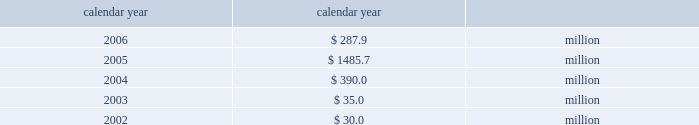Taxes .
If group or its bermuda subsidiaries were to become subject to u.s .
Income tax ; there could be a material adverse effect on the company 2019s financial condition , results of operations and cash flows .
United kingdom .
Bermuda re 2019s uk branch conducts business in the uk and is subject to taxation in the uk .
Bermuda re believes that it has operated and will continue to operate its bermuda operation in a manner which will not cause them to be subject to uk taxation .
If bermuda re 2019s bermuda operations were to become subject to uk income tax there could be a material adverse impact on the company 2019s financial condition , results of operations and cash flow .
Available information the company 2019s annual reports on form 10-k , quarterly reports on form 10-q , current reports on form 8-k , proxy state- ments and amendments to those reports are available free of charge through the company 2019s internet website at http://www.everestre.com as soon as reasonably practicable after such reports are electronically filed with the securities and exchange commission ( the 201csec 201d ) .
I t e m 1 a .
R i s k f a c t o r s in addition to the other information provided in this report , the following risk factors should be considered when evaluating an investment in our securities .
If the circumstances contemplated by the individual risk factors materialize , our business , finan- cial condition and results of operations could be materially and adversely affected and the trading price of our common shares could decline significantly .
R i s k s r e l a t i n g t o o u r b u s i n e s s our results could be adversely affected by catastrophic events .
We are exposed to unpredictable catastrophic events , including weather-related and other natural catastrophes , as well as acts of terrorism .
Any material reduction in our operating results caused by the occurrence of one or more catastrophes could inhibit our ability to pay dividends or to meet our interest and principal payment obligations .
We define a catastrophe as an event that causes a pre-tax loss on property exposures before reinsurance of at least $ 5.0 million , before corporate level rein- surance and taxes .
Effective for the third quarter 2005 , industrial risk losses have been excluded from catastrophe losses , with prior periods adjusted for comparison purposes .
By way of illustration , during the past five calendar years , pre-tax catastrophe losses , net of contract specific reinsurance but before cessions under corporate reinsurance programs , were as follows: .
Our losses from future catastrophic events could exceed our projections .
We use projections of possible losses from future catastrophic events of varying types and magnitudes as a strategic under- writing tool .
We use these loss projections to estimate our potential catastrophe losses in certain geographic areas and decide on the purchase of retrocessional coverage or other actions to limit the extent of potential losses in a given geographic area .
These loss projections are approximations reliant on a mix of quantitative and qualitative processes and actual losses may exceed the projections by a material amount .
We focus on potential losses that can be generated by any single event as part of our evaluation and monitoring of our aggre- gate exposure to catastrophic events .
Accordingly , we employ various techniques to estimate the amount of loss we could sustain from any single catastrophic event in various geographical areas .
These techniques range from non-modeled deterministic approaches 2014such as tracking aggregate limits exposed in catastrophe-prone zones and applying historic dam- age factors 2014to modeled approaches that scientifically measure catastrophe risks using sophisticated monte carlo simulation techniques that provide insights into the frequency and severity of expected losses on a probabilistic basis .
If our loss reserves are inadequate to meet our actual losses , net income would be reduced or we could incur a loss .
We are required to maintain reserves to cover our estimated ultimate liability of losses and loss adjustment expenses for both reported and unreported claims incurred .
These reserves are only estimates of what we believe the settlement and adminis- tration of claims will cost based on facts and circumstances known to us .
In setting reserves for our reinsurance liabilities , we rely on claim data supplied by our ceding companies and brokers and we employ actuarial and statistical projections .
The information received from our ceding companies is not always timely or accurate , which can contribute to inaccuracies in our 81790fin_a 4/13/07 11:08 am page 23 http://www.everestre.com .
What are the total pre-tax catastrophe losses in the last two years? 
Computations: (287.9 + 1485.7)
Answer: 1773.6. Taxes .
If group or its bermuda subsidiaries were to become subject to u.s .
Income tax ; there could be a material adverse effect on the company 2019s financial condition , results of operations and cash flows .
United kingdom .
Bermuda re 2019s uk branch conducts business in the uk and is subject to taxation in the uk .
Bermuda re believes that it has operated and will continue to operate its bermuda operation in a manner which will not cause them to be subject to uk taxation .
If bermuda re 2019s bermuda operations were to become subject to uk income tax there could be a material adverse impact on the company 2019s financial condition , results of operations and cash flow .
Available information the company 2019s annual reports on form 10-k , quarterly reports on form 10-q , current reports on form 8-k , proxy state- ments and amendments to those reports are available free of charge through the company 2019s internet website at http://www.everestre.com as soon as reasonably practicable after such reports are electronically filed with the securities and exchange commission ( the 201csec 201d ) .
I t e m 1 a .
R i s k f a c t o r s in addition to the other information provided in this report , the following risk factors should be considered when evaluating an investment in our securities .
If the circumstances contemplated by the individual risk factors materialize , our business , finan- cial condition and results of operations could be materially and adversely affected and the trading price of our common shares could decline significantly .
R i s k s r e l a t i n g t o o u r b u s i n e s s our results could be adversely affected by catastrophic events .
We are exposed to unpredictable catastrophic events , including weather-related and other natural catastrophes , as well as acts of terrorism .
Any material reduction in our operating results caused by the occurrence of one or more catastrophes could inhibit our ability to pay dividends or to meet our interest and principal payment obligations .
We define a catastrophe as an event that causes a pre-tax loss on property exposures before reinsurance of at least $ 5.0 million , before corporate level rein- surance and taxes .
Effective for the third quarter 2005 , industrial risk losses have been excluded from catastrophe losses , with prior periods adjusted for comparison purposes .
By way of illustration , during the past five calendar years , pre-tax catastrophe losses , net of contract specific reinsurance but before cessions under corporate reinsurance programs , were as follows: .
Our losses from future catastrophic events could exceed our projections .
We use projections of possible losses from future catastrophic events of varying types and magnitudes as a strategic under- writing tool .
We use these loss projections to estimate our potential catastrophe losses in certain geographic areas and decide on the purchase of retrocessional coverage or other actions to limit the extent of potential losses in a given geographic area .
These loss projections are approximations reliant on a mix of quantitative and qualitative processes and actual losses may exceed the projections by a material amount .
We focus on potential losses that can be generated by any single event as part of our evaluation and monitoring of our aggre- gate exposure to catastrophic events .
Accordingly , we employ various techniques to estimate the amount of loss we could sustain from any single catastrophic event in various geographical areas .
These techniques range from non-modeled deterministic approaches 2014such as tracking aggregate limits exposed in catastrophe-prone zones and applying historic dam- age factors 2014to modeled approaches that scientifically measure catastrophe risks using sophisticated monte carlo simulation techniques that provide insights into the frequency and severity of expected losses on a probabilistic basis .
If our loss reserves are inadequate to meet our actual losses , net income would be reduced or we could incur a loss .
We are required to maintain reserves to cover our estimated ultimate liability of losses and loss adjustment expenses for both reported and unreported claims incurred .
These reserves are only estimates of what we believe the settlement and adminis- tration of claims will cost based on facts and circumstances known to us .
In setting reserves for our reinsurance liabilities , we rely on claim data supplied by our ceding companies and brokers and we employ actuarial and statistical projections .
The information received from our ceding companies is not always timely or accurate , which can contribute to inaccuracies in our 81790fin_a 4/13/07 11:08 am page 23 http://www.everestre.com .
What was the change in the amount of the , pre-tax catastrophe losses from 2004 to 2005 in thousands? 
Computations: (1485.7 - 390.0)
Answer: 1095.7. 